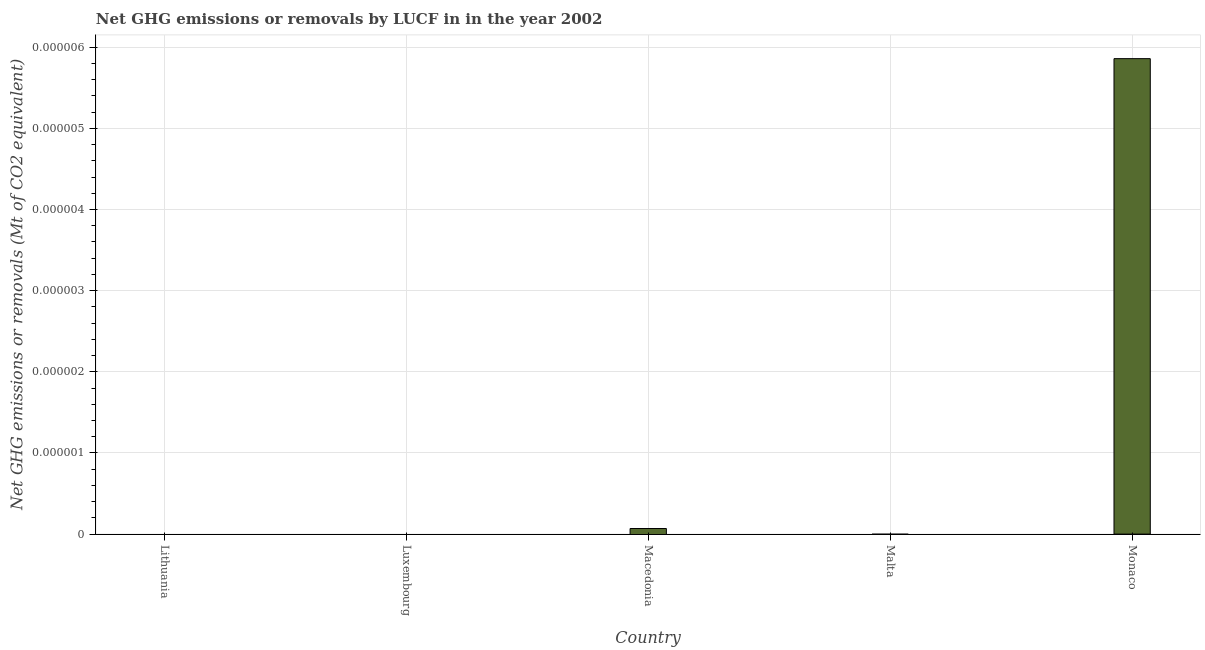Does the graph contain any zero values?
Your answer should be compact. Yes. What is the title of the graph?
Your response must be concise. Net GHG emissions or removals by LUCF in in the year 2002. What is the label or title of the Y-axis?
Provide a short and direct response. Net GHG emissions or removals (Mt of CO2 equivalent). Across all countries, what is the maximum ghg net emissions or removals?
Give a very brief answer. 5.858356041736519e-6. Across all countries, what is the minimum ghg net emissions or removals?
Offer a terse response. 0. In which country was the ghg net emissions or removals maximum?
Keep it short and to the point. Monaco. What is the sum of the ghg net emissions or removals?
Your response must be concise. 5.858356041736519e-6. What is the median ghg net emissions or removals?
Provide a short and direct response. 0. In how many countries, is the ghg net emissions or removals greater than 1.4e-06 Mt?
Your response must be concise. 1. Are all the bars in the graph horizontal?
Offer a terse response. No. How many countries are there in the graph?
Provide a succinct answer. 5. What is the difference between two consecutive major ticks on the Y-axis?
Ensure brevity in your answer.  1e-6. Are the values on the major ticks of Y-axis written in scientific E-notation?
Ensure brevity in your answer.  No. What is the Net GHG emissions or removals (Mt of CO2 equivalent) of Luxembourg?
Keep it short and to the point. 0. What is the Net GHG emissions or removals (Mt of CO2 equivalent) in Malta?
Ensure brevity in your answer.  0. What is the Net GHG emissions or removals (Mt of CO2 equivalent) of Monaco?
Your response must be concise. 5.858356041736519e-6. 